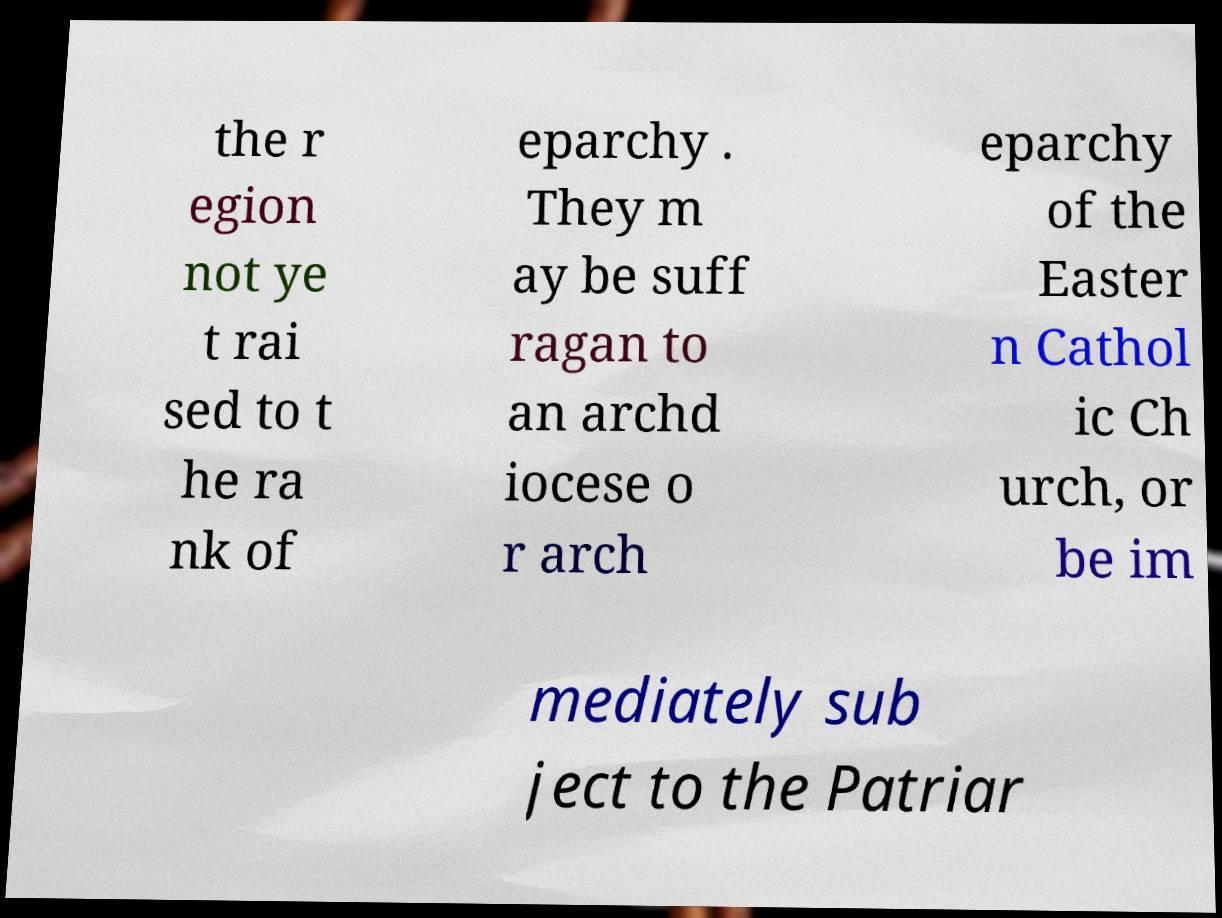There's text embedded in this image that I need extracted. Can you transcribe it verbatim? the r egion not ye t rai sed to t he ra nk of eparchy . They m ay be suff ragan to an archd iocese o r arch eparchy of the Easter n Cathol ic Ch urch, or be im mediately sub ject to the Patriar 